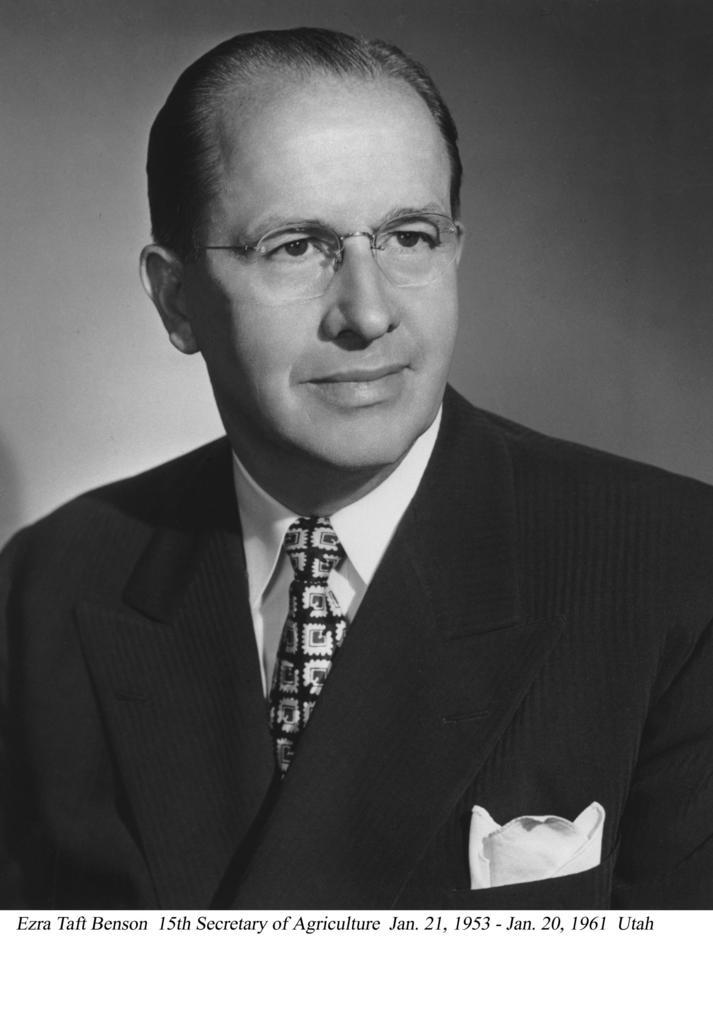Who is present in the image? There is a man in the picture. What is the man wearing? The man is wearing a coat, a shirt, and a tie. What is the color scheme of the image? The image is black and white in color. Is there any text or writing on the image? Yes, there is text or writing on the image. What type of music can be heard playing from the shelf in the image? There is no shelf or music present in the image; it features a man wearing a coat, shirt, and tie in a black and white setting with text or writing. 